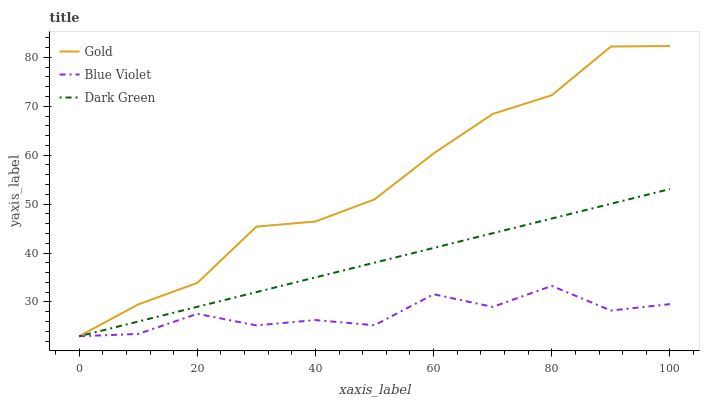Does Blue Violet have the minimum area under the curve?
Answer yes or no. Yes. Does Gold have the maximum area under the curve?
Answer yes or no. Yes. Does Dark Green have the minimum area under the curve?
Answer yes or no. No. Does Dark Green have the maximum area under the curve?
Answer yes or no. No. Is Dark Green the smoothest?
Answer yes or no. Yes. Is Blue Violet the roughest?
Answer yes or no. Yes. Is Gold the smoothest?
Answer yes or no. No. Is Gold the roughest?
Answer yes or no. No. Does Blue Violet have the lowest value?
Answer yes or no. Yes. Does Gold have the highest value?
Answer yes or no. Yes. Does Dark Green have the highest value?
Answer yes or no. No. Does Gold intersect Blue Violet?
Answer yes or no. Yes. Is Gold less than Blue Violet?
Answer yes or no. No. Is Gold greater than Blue Violet?
Answer yes or no. No. 